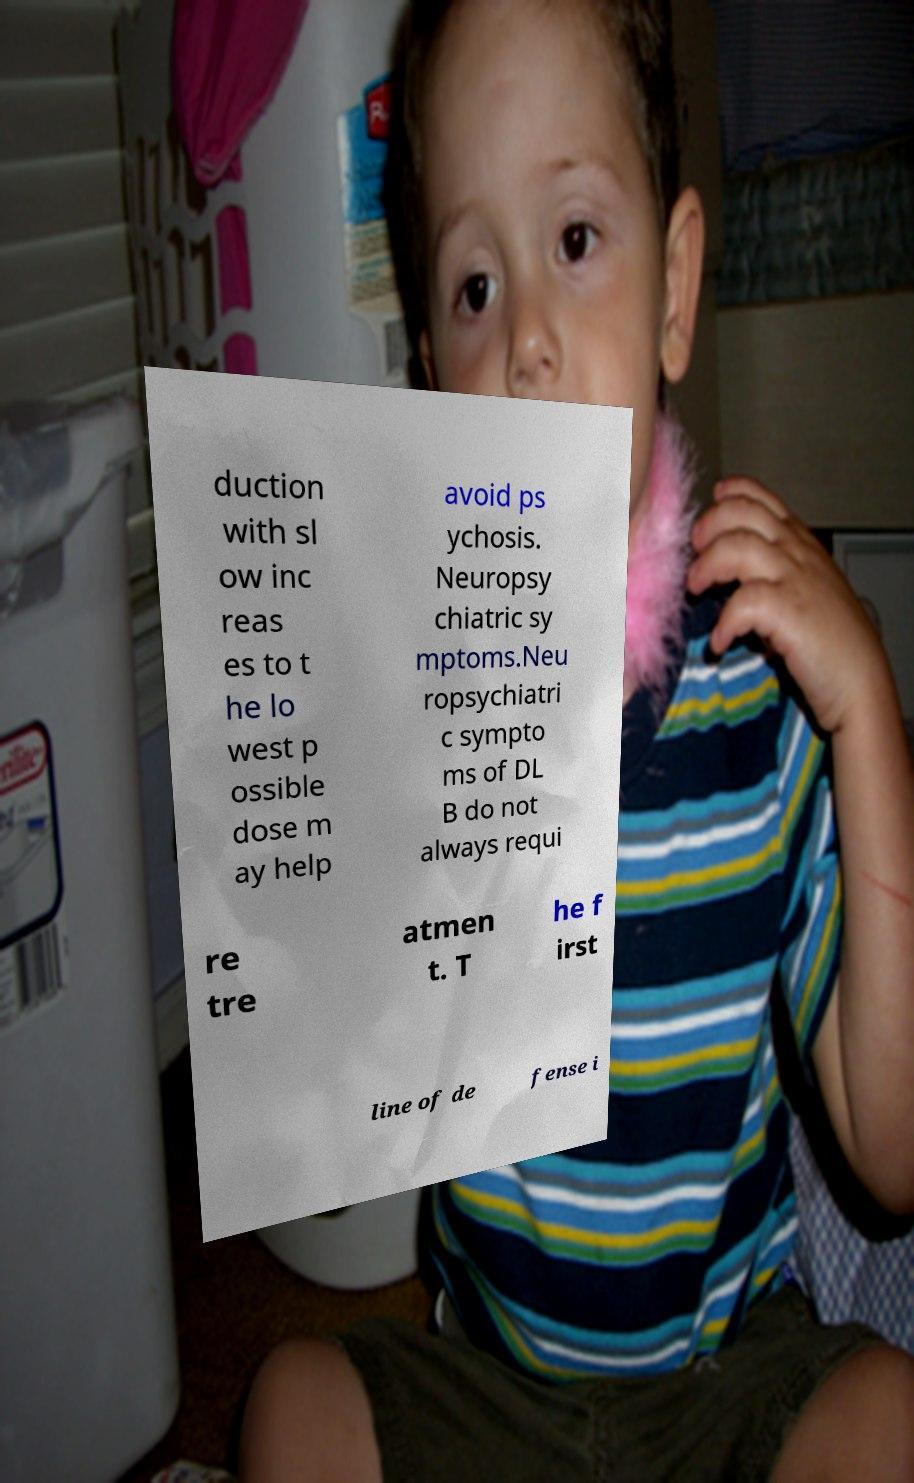Can you accurately transcribe the text from the provided image for me? duction with sl ow inc reas es to t he lo west p ossible dose m ay help avoid ps ychosis. Neuropsy chiatric sy mptoms.Neu ropsychiatri c sympto ms of DL B do not always requi re tre atmen t. T he f irst line of de fense i 